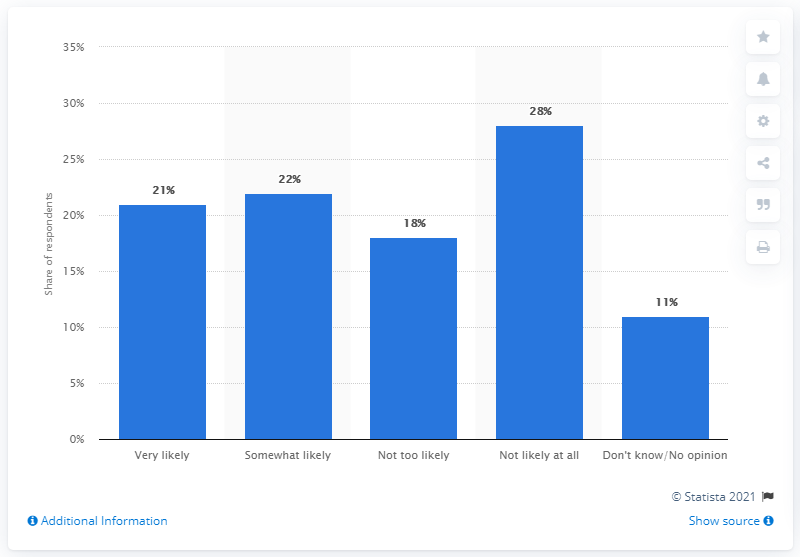Highlight a few significant elements in this photo. The sum of respondents who are very likely and somewhat likely to purchase is more likely than not, whereas those who are not likely at all to purchase is unlikely. According to the survey results, 21% of respondents are very likely to purchase wearables such as Fitbit or smartwatches. 